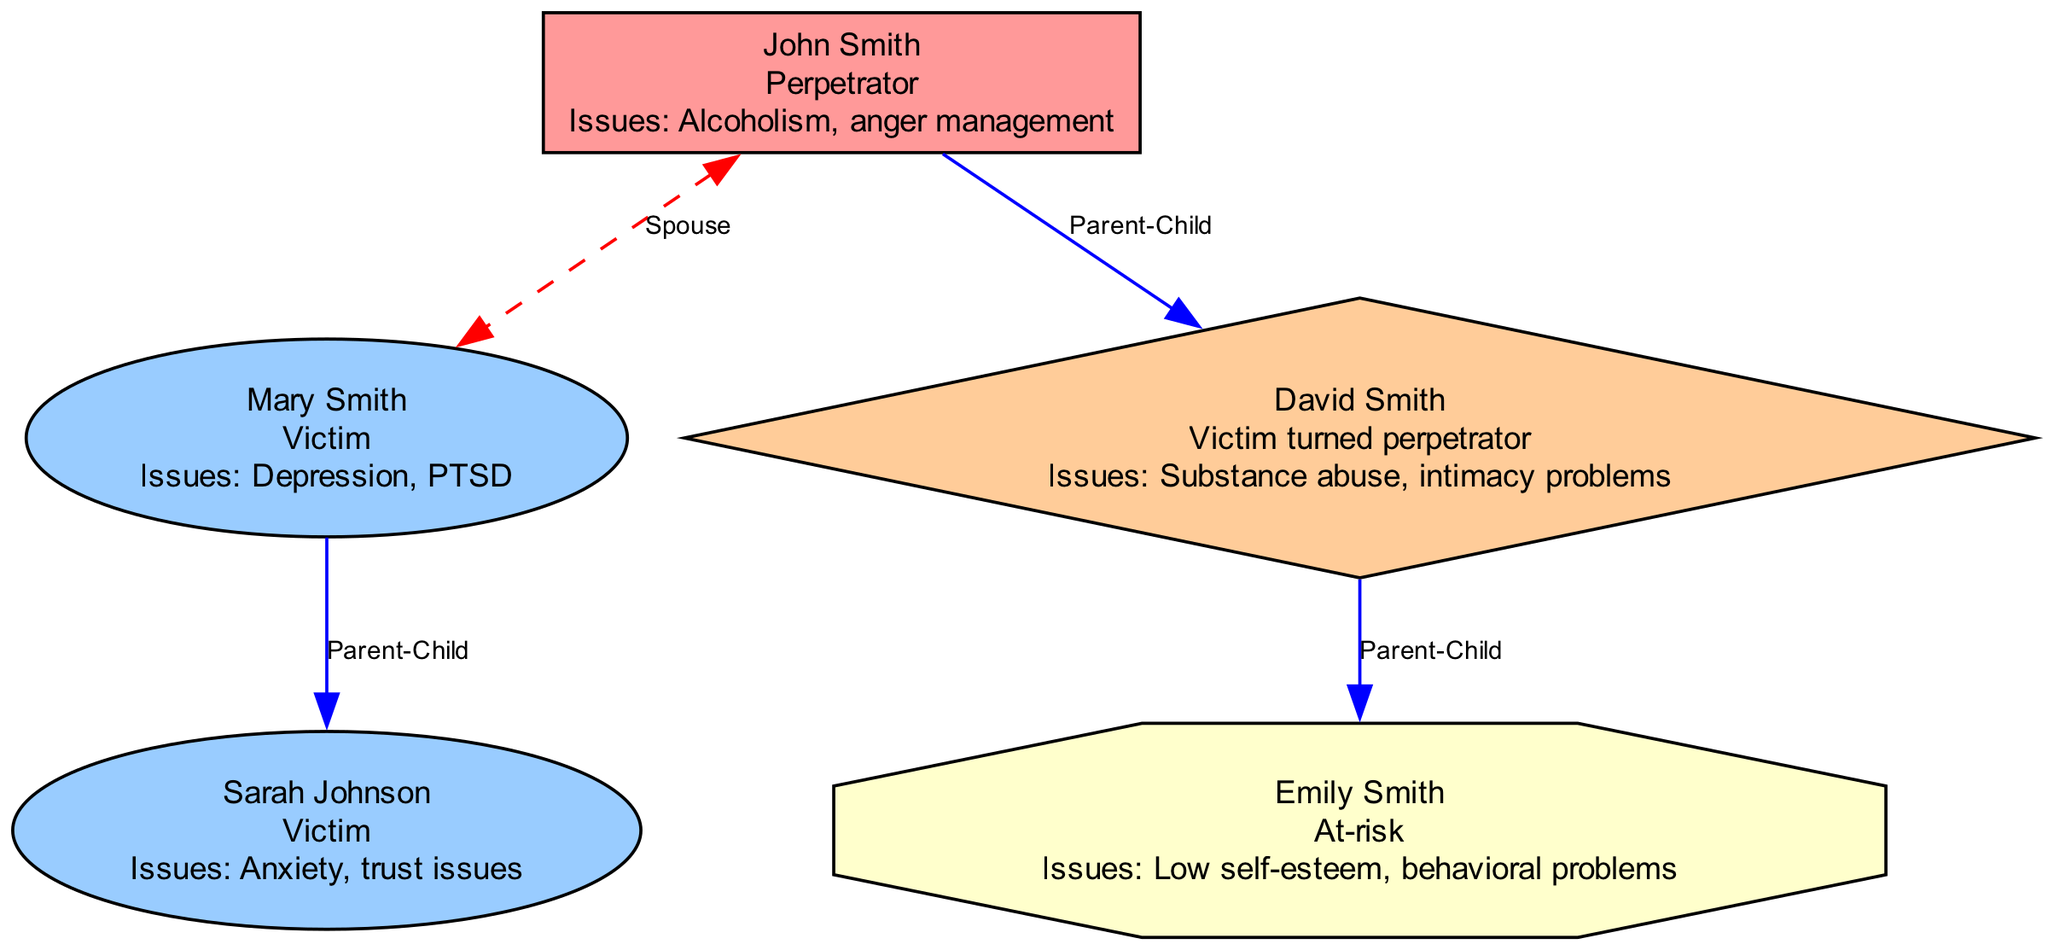What is the status of John Smith? The diagram indicates that John Smith is labeled as a "Perpetrator." This is directly stated in the node for John Smith within the diagram.
Answer: Perpetrator How many generations are represented in the family tree? The diagram displays members from three distinct generations. This includes the first generation (John and Mary), the second generation (David and Sarah), and the third generation (Emily). By counting the generations visible in the diagram, we find three.
Answer: 3 Who is the spouse of Mary Smith? The relationship line labeled "Spouse" connects John Smith to Mary Smith in the diagram. Based on the relationships shown, John Smith is identified as Mary's spouse.
Answer: John Smith What issues does Sarah Johnson have? The diagram specifically lists "Anxiety, trust issues" as the issues associated with Sarah Johnson. This information is directly presented in her node.
Answer: Anxiety, trust issues What kind of parenting did David Smith provide to Emily Smith? The relationship details state that David Smith practiced "Neglectful parenting" with regard to Emily Smith, as indicated in the parenting relationship in the diagram.
Answer: Neglectful parenting Which family member is at-risk? The diagram labels Emily Smith as "At-risk." This status is clearly indicated in her node on the family tree.
Answer: Emily Smith How many victims are in the second generation? In the second generation, both Sarah Johnson and David Smith have victim labels associated with them. The count reveals two victims within this generation.
Answer: 2 What type of relationship exists between John and David Smith? The diagram specifies a "Parent-Child" relationship between John Smith and David Smith. This relationship is illustrated with a solid blue line connecting them in the diagram.
Answer: Parent-Child Which family member has issues related to substance abuse? The node for David Smith states that he has issues concerning "Substance abuse," clearly identifying him as having these specific issues.
Answer: David Smith 